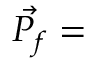Convert formula to latex. <formula><loc_0><loc_0><loc_500><loc_500>\vec { P _ { f } } =</formula> 